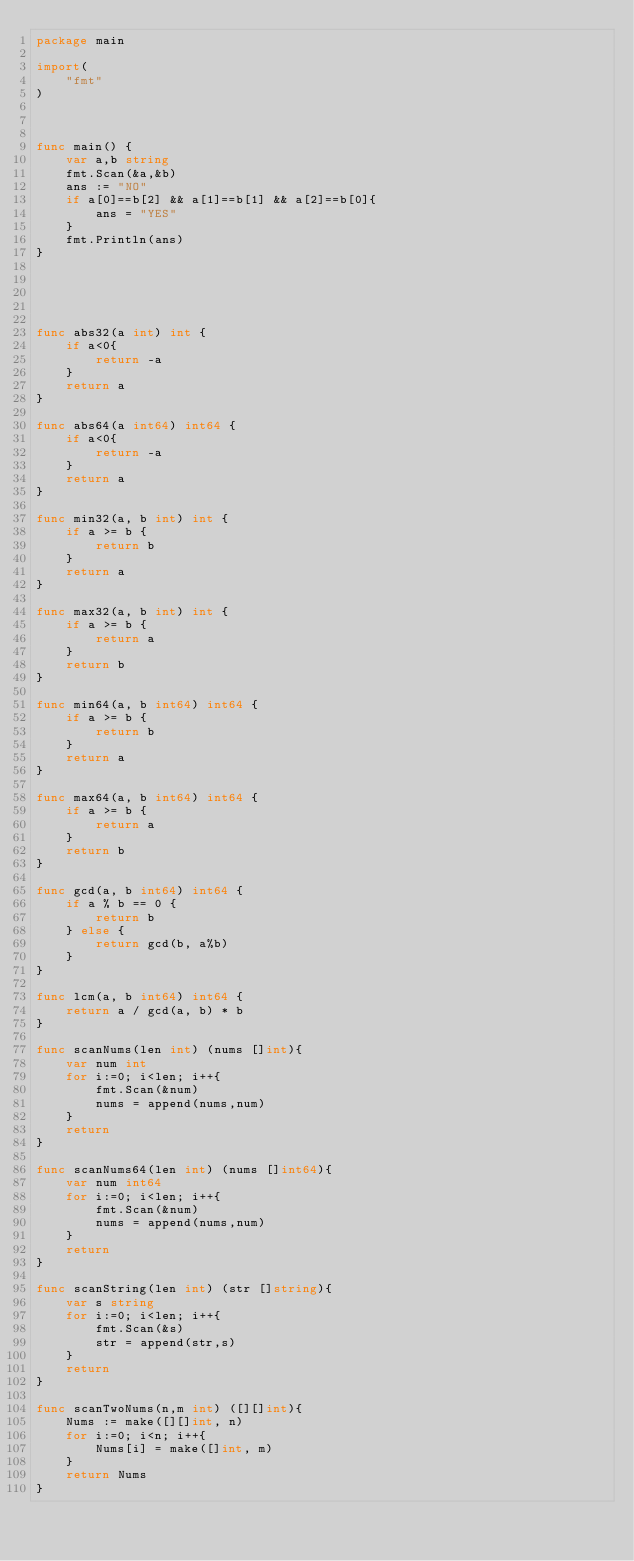<code> <loc_0><loc_0><loc_500><loc_500><_Go_>package main

import(
    "fmt"
)



func main() {
    var a,b string
    fmt.Scan(&a,&b)
    ans := "NO"
    if a[0]==b[2] && a[1]==b[1] && a[2]==b[0]{
        ans = "YES"
    }
    fmt.Println(ans)
}





func abs32(a int) int {
    if a<0{
        return -a
    }
    return a
}

func abs64(a int64) int64 {
    if a<0{
        return -a
    }
    return a
}

func min32(a, b int) int {
    if a >= b {
        return b
    }
    return a
}

func max32(a, b int) int {
    if a >= b {
        return a
    }
    return b
}

func min64(a, b int64) int64 {
    if a >= b {
        return b
    }
    return a
}

func max64(a, b int64) int64 {
    if a >= b {
        return a
    }
    return b
}

func gcd(a, b int64) int64 {
    if a % b == 0 {
        return b
    } else {
        return gcd(b, a%b)
    }
}

func lcm(a, b int64) int64 {
    return a / gcd(a, b) * b
}

func scanNums(len int) (nums []int){
    var num int
    for i:=0; i<len; i++{
        fmt.Scan(&num)
        nums = append(nums,num)
    }
    return
}

func scanNums64(len int) (nums []int64){
    var num int64
    for i:=0; i<len; i++{
        fmt.Scan(&num)
        nums = append(nums,num)
    }
    return
}

func scanString(len int) (str []string){
    var s string
    for i:=0; i<len; i++{
        fmt.Scan(&s)
        str = append(str,s)
    }
    return
}

func scanTwoNums(n,m int) ([][]int){
    Nums := make([][]int, n)
    for i:=0; i<n; i++{
        Nums[i] = make([]int, m)
    }
    return Nums
}
</code> 